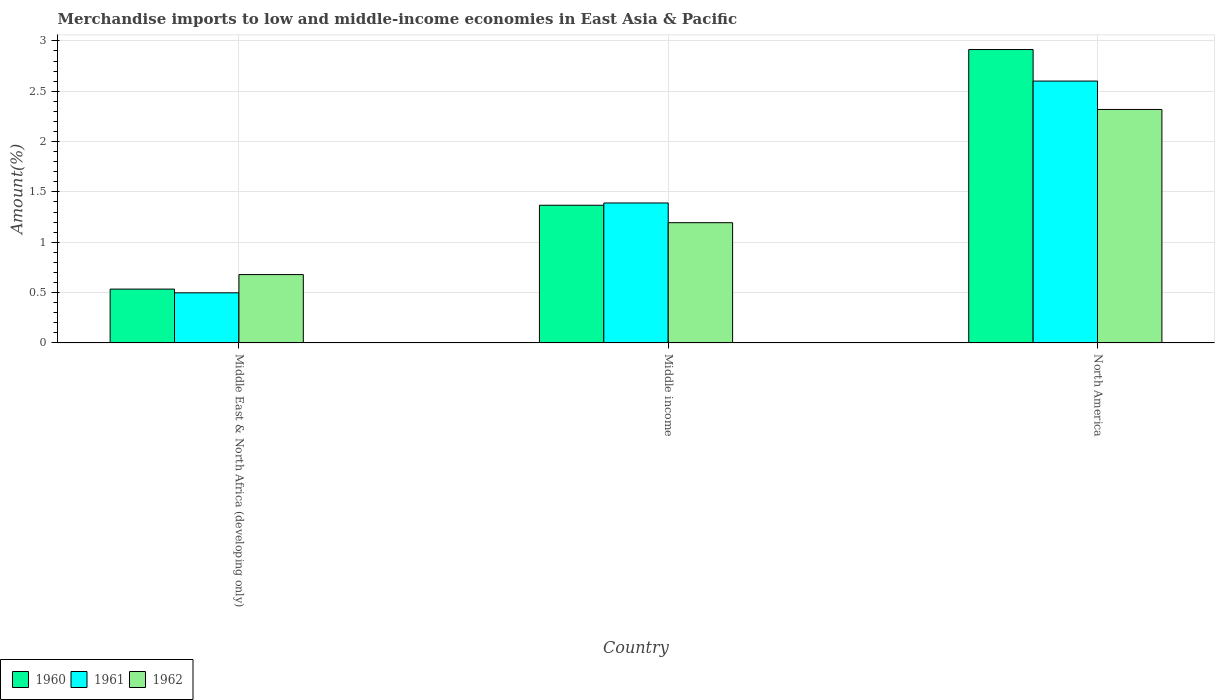How many different coloured bars are there?
Your answer should be very brief. 3. How many groups of bars are there?
Ensure brevity in your answer.  3. Are the number of bars on each tick of the X-axis equal?
Your response must be concise. Yes. How many bars are there on the 2nd tick from the left?
Your response must be concise. 3. What is the label of the 1st group of bars from the left?
Offer a terse response. Middle East & North Africa (developing only). What is the percentage of amount earned from merchandise imports in 1962 in Middle East & North Africa (developing only)?
Make the answer very short. 0.68. Across all countries, what is the maximum percentage of amount earned from merchandise imports in 1961?
Ensure brevity in your answer.  2.6. Across all countries, what is the minimum percentage of amount earned from merchandise imports in 1961?
Make the answer very short. 0.5. In which country was the percentage of amount earned from merchandise imports in 1962 minimum?
Your response must be concise. Middle East & North Africa (developing only). What is the total percentage of amount earned from merchandise imports in 1961 in the graph?
Ensure brevity in your answer.  4.49. What is the difference between the percentage of amount earned from merchandise imports in 1961 in Middle East & North Africa (developing only) and that in North America?
Your answer should be compact. -2.1. What is the difference between the percentage of amount earned from merchandise imports in 1961 in North America and the percentage of amount earned from merchandise imports in 1960 in Middle East & North Africa (developing only)?
Your answer should be compact. 2.07. What is the average percentage of amount earned from merchandise imports in 1960 per country?
Offer a very short reply. 1.61. What is the difference between the percentage of amount earned from merchandise imports of/in 1960 and percentage of amount earned from merchandise imports of/in 1962 in Middle income?
Provide a succinct answer. 0.17. In how many countries, is the percentage of amount earned from merchandise imports in 1961 greater than 0.1 %?
Give a very brief answer. 3. What is the ratio of the percentage of amount earned from merchandise imports in 1960 in Middle East & North Africa (developing only) to that in North America?
Provide a succinct answer. 0.18. Is the difference between the percentage of amount earned from merchandise imports in 1960 in Middle East & North Africa (developing only) and Middle income greater than the difference between the percentage of amount earned from merchandise imports in 1962 in Middle East & North Africa (developing only) and Middle income?
Your response must be concise. No. What is the difference between the highest and the second highest percentage of amount earned from merchandise imports in 1961?
Your answer should be compact. -0.89. What is the difference between the highest and the lowest percentage of amount earned from merchandise imports in 1961?
Provide a succinct answer. 2.1. Is the sum of the percentage of amount earned from merchandise imports in 1962 in Middle East & North Africa (developing only) and Middle income greater than the maximum percentage of amount earned from merchandise imports in 1961 across all countries?
Provide a short and direct response. No. What does the 1st bar from the right in North America represents?
Ensure brevity in your answer.  1962. How many bars are there?
Provide a succinct answer. 9. What is the difference between two consecutive major ticks on the Y-axis?
Your response must be concise. 0.5. Does the graph contain grids?
Make the answer very short. Yes. How many legend labels are there?
Your answer should be compact. 3. What is the title of the graph?
Ensure brevity in your answer.  Merchandise imports to low and middle-income economies in East Asia & Pacific. Does "2008" appear as one of the legend labels in the graph?
Keep it short and to the point. No. What is the label or title of the Y-axis?
Ensure brevity in your answer.  Amount(%). What is the Amount(%) in 1960 in Middle East & North Africa (developing only)?
Ensure brevity in your answer.  0.53. What is the Amount(%) of 1961 in Middle East & North Africa (developing only)?
Provide a succinct answer. 0.5. What is the Amount(%) of 1962 in Middle East & North Africa (developing only)?
Provide a short and direct response. 0.68. What is the Amount(%) in 1960 in Middle income?
Offer a terse response. 1.37. What is the Amount(%) of 1961 in Middle income?
Provide a succinct answer. 1.39. What is the Amount(%) in 1962 in Middle income?
Offer a terse response. 1.19. What is the Amount(%) in 1960 in North America?
Provide a succinct answer. 2.91. What is the Amount(%) in 1961 in North America?
Your answer should be very brief. 2.6. What is the Amount(%) of 1962 in North America?
Your answer should be compact. 2.32. Across all countries, what is the maximum Amount(%) in 1960?
Make the answer very short. 2.91. Across all countries, what is the maximum Amount(%) of 1961?
Ensure brevity in your answer.  2.6. Across all countries, what is the maximum Amount(%) of 1962?
Offer a terse response. 2.32. Across all countries, what is the minimum Amount(%) in 1960?
Your answer should be very brief. 0.53. Across all countries, what is the minimum Amount(%) of 1961?
Make the answer very short. 0.5. Across all countries, what is the minimum Amount(%) of 1962?
Offer a very short reply. 0.68. What is the total Amount(%) of 1960 in the graph?
Provide a succinct answer. 4.82. What is the total Amount(%) in 1961 in the graph?
Provide a succinct answer. 4.49. What is the total Amount(%) of 1962 in the graph?
Offer a very short reply. 4.19. What is the difference between the Amount(%) in 1960 in Middle East & North Africa (developing only) and that in Middle income?
Offer a very short reply. -0.83. What is the difference between the Amount(%) of 1961 in Middle East & North Africa (developing only) and that in Middle income?
Ensure brevity in your answer.  -0.89. What is the difference between the Amount(%) of 1962 in Middle East & North Africa (developing only) and that in Middle income?
Give a very brief answer. -0.52. What is the difference between the Amount(%) of 1960 in Middle East & North Africa (developing only) and that in North America?
Your response must be concise. -2.38. What is the difference between the Amount(%) of 1961 in Middle East & North Africa (developing only) and that in North America?
Offer a very short reply. -2.1. What is the difference between the Amount(%) in 1962 in Middle East & North Africa (developing only) and that in North America?
Make the answer very short. -1.64. What is the difference between the Amount(%) of 1960 in Middle income and that in North America?
Make the answer very short. -1.55. What is the difference between the Amount(%) in 1961 in Middle income and that in North America?
Make the answer very short. -1.21. What is the difference between the Amount(%) in 1962 in Middle income and that in North America?
Ensure brevity in your answer.  -1.12. What is the difference between the Amount(%) in 1960 in Middle East & North Africa (developing only) and the Amount(%) in 1961 in Middle income?
Provide a short and direct response. -0.86. What is the difference between the Amount(%) in 1960 in Middle East & North Africa (developing only) and the Amount(%) in 1962 in Middle income?
Your answer should be compact. -0.66. What is the difference between the Amount(%) of 1961 in Middle East & North Africa (developing only) and the Amount(%) of 1962 in Middle income?
Offer a very short reply. -0.7. What is the difference between the Amount(%) in 1960 in Middle East & North Africa (developing only) and the Amount(%) in 1961 in North America?
Your answer should be compact. -2.07. What is the difference between the Amount(%) in 1960 in Middle East & North Africa (developing only) and the Amount(%) in 1962 in North America?
Your response must be concise. -1.78. What is the difference between the Amount(%) in 1961 in Middle East & North Africa (developing only) and the Amount(%) in 1962 in North America?
Keep it short and to the point. -1.82. What is the difference between the Amount(%) of 1960 in Middle income and the Amount(%) of 1961 in North America?
Your answer should be very brief. -1.23. What is the difference between the Amount(%) in 1960 in Middle income and the Amount(%) in 1962 in North America?
Ensure brevity in your answer.  -0.95. What is the difference between the Amount(%) of 1961 in Middle income and the Amount(%) of 1962 in North America?
Give a very brief answer. -0.93. What is the average Amount(%) of 1960 per country?
Your answer should be very brief. 1.61. What is the average Amount(%) of 1961 per country?
Give a very brief answer. 1.5. What is the average Amount(%) of 1962 per country?
Your answer should be compact. 1.4. What is the difference between the Amount(%) in 1960 and Amount(%) in 1961 in Middle East & North Africa (developing only)?
Offer a terse response. 0.04. What is the difference between the Amount(%) in 1960 and Amount(%) in 1962 in Middle East & North Africa (developing only)?
Provide a short and direct response. -0.14. What is the difference between the Amount(%) of 1961 and Amount(%) of 1962 in Middle East & North Africa (developing only)?
Offer a very short reply. -0.18. What is the difference between the Amount(%) of 1960 and Amount(%) of 1961 in Middle income?
Provide a succinct answer. -0.02. What is the difference between the Amount(%) of 1960 and Amount(%) of 1962 in Middle income?
Provide a short and direct response. 0.17. What is the difference between the Amount(%) in 1961 and Amount(%) in 1962 in Middle income?
Provide a succinct answer. 0.2. What is the difference between the Amount(%) of 1960 and Amount(%) of 1961 in North America?
Provide a short and direct response. 0.31. What is the difference between the Amount(%) of 1960 and Amount(%) of 1962 in North America?
Offer a very short reply. 0.6. What is the difference between the Amount(%) of 1961 and Amount(%) of 1962 in North America?
Your answer should be very brief. 0.28. What is the ratio of the Amount(%) in 1960 in Middle East & North Africa (developing only) to that in Middle income?
Your response must be concise. 0.39. What is the ratio of the Amount(%) of 1961 in Middle East & North Africa (developing only) to that in Middle income?
Give a very brief answer. 0.36. What is the ratio of the Amount(%) of 1962 in Middle East & North Africa (developing only) to that in Middle income?
Provide a succinct answer. 0.57. What is the ratio of the Amount(%) of 1960 in Middle East & North Africa (developing only) to that in North America?
Provide a short and direct response. 0.18. What is the ratio of the Amount(%) of 1961 in Middle East & North Africa (developing only) to that in North America?
Offer a terse response. 0.19. What is the ratio of the Amount(%) of 1962 in Middle East & North Africa (developing only) to that in North America?
Offer a terse response. 0.29. What is the ratio of the Amount(%) of 1960 in Middle income to that in North America?
Provide a succinct answer. 0.47. What is the ratio of the Amount(%) of 1961 in Middle income to that in North America?
Offer a terse response. 0.53. What is the ratio of the Amount(%) of 1962 in Middle income to that in North America?
Your answer should be very brief. 0.52. What is the difference between the highest and the second highest Amount(%) in 1960?
Your response must be concise. 1.55. What is the difference between the highest and the second highest Amount(%) in 1961?
Offer a terse response. 1.21. What is the difference between the highest and the second highest Amount(%) in 1962?
Provide a short and direct response. 1.12. What is the difference between the highest and the lowest Amount(%) in 1960?
Your response must be concise. 2.38. What is the difference between the highest and the lowest Amount(%) in 1961?
Your response must be concise. 2.1. What is the difference between the highest and the lowest Amount(%) of 1962?
Your response must be concise. 1.64. 